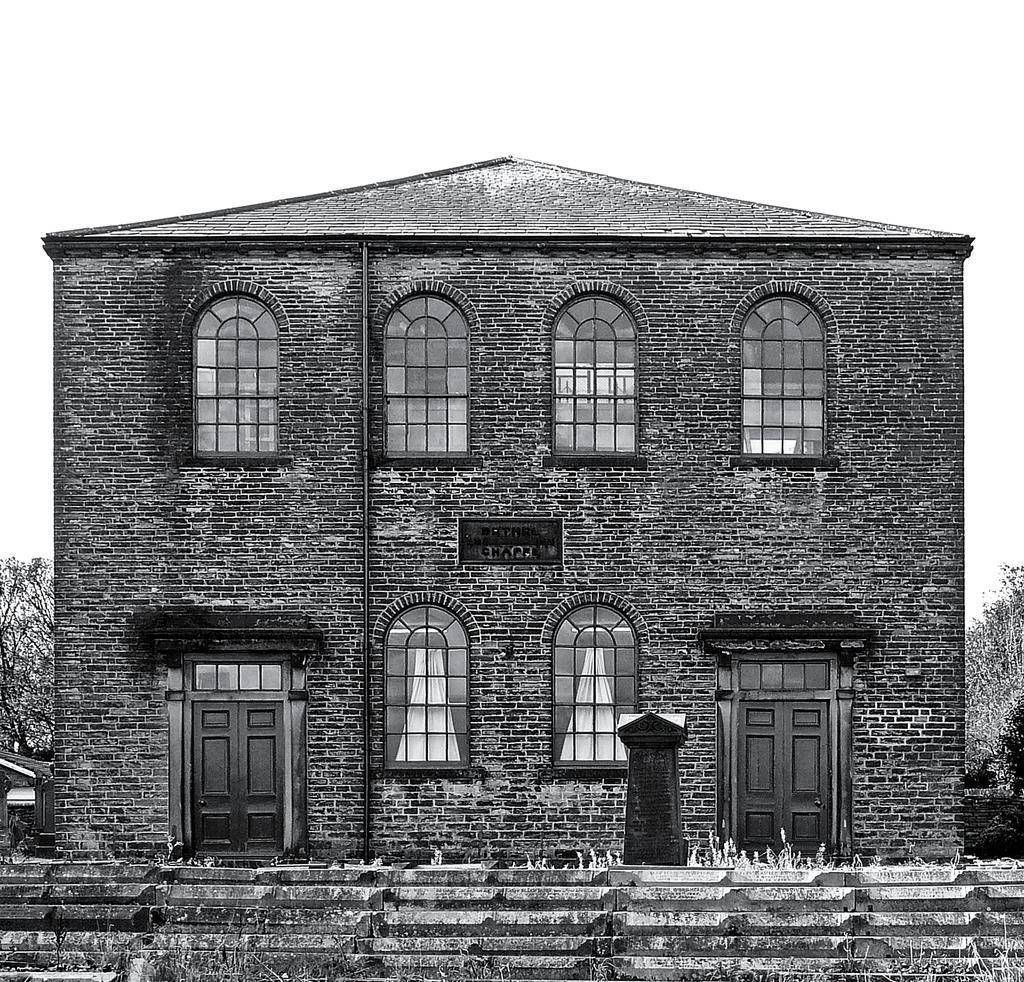In one or two sentences, can you explain what this image depicts? In the picture we can see a sketch of the house with four windows on the top with glasses to it and two doors and near it we can see some steps and besides the house we can see some trees. 